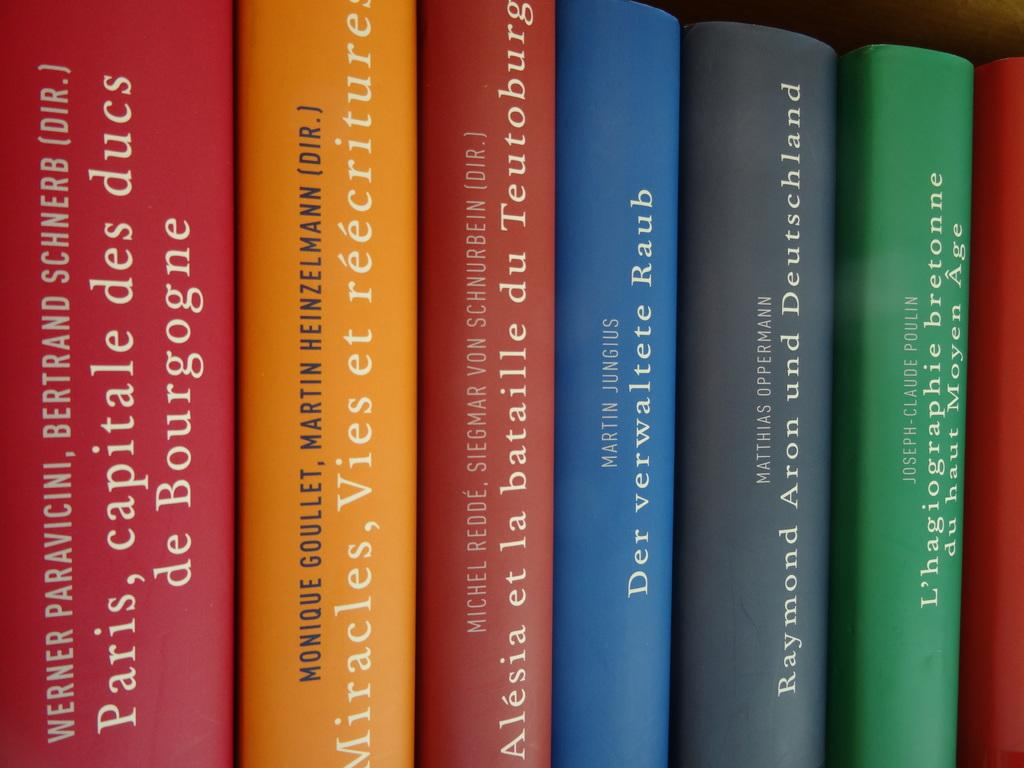Provide a one-sentence caption for the provided image. a line of different colored bookcs with the middle one written by martin jungus. 